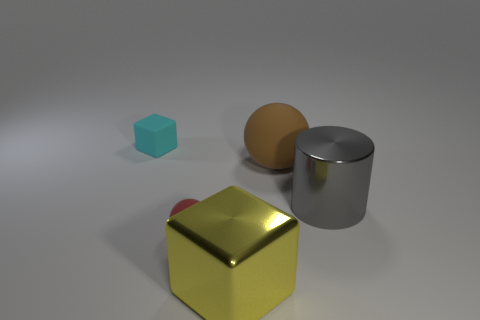What might be the function of these objects if they were real? If these objects were real, they could serve a variety of functions. The golden cube might be a paperweight or decorative item, the sphere could be a part of a rolling mechanism or a child's toy, the cyan cube might be a crafting block, and the cylinder could be a container or a part of some machinery. Their functions could be as diverse as their appearances. 